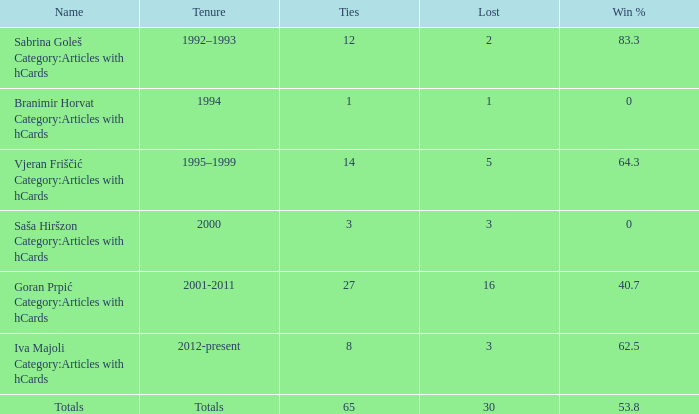I want the total number of ties for win % more than 0 and tenure of 2001-2011 with lost more than 16 0.0. 